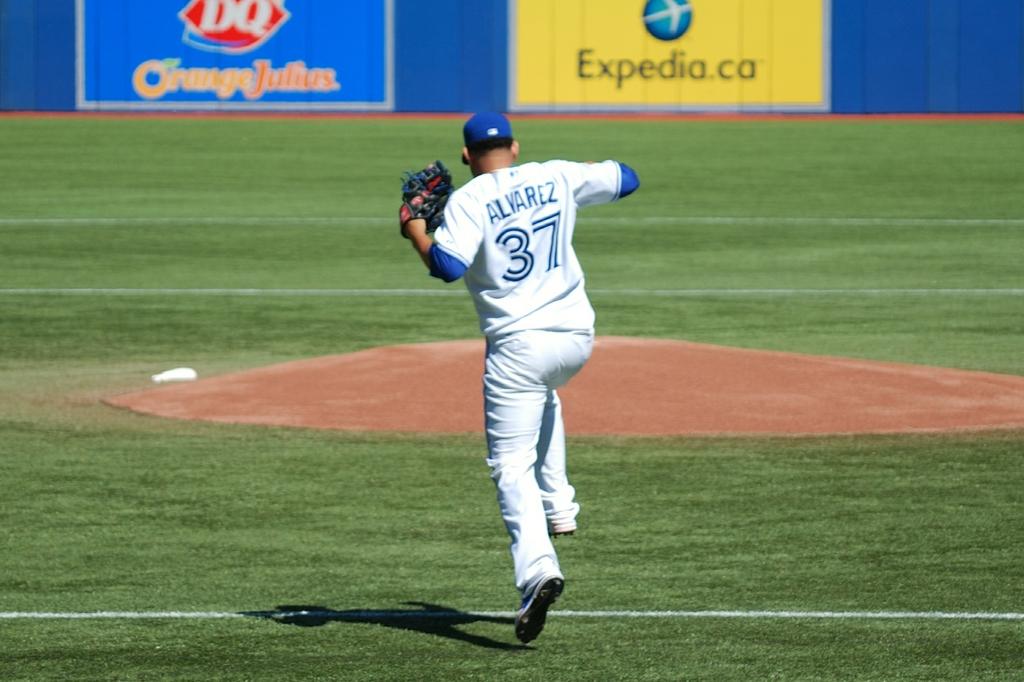What brand is advertised on the left billboard?
Offer a very short reply. Dq. What is the number on the uniform?
Offer a terse response. 37. 